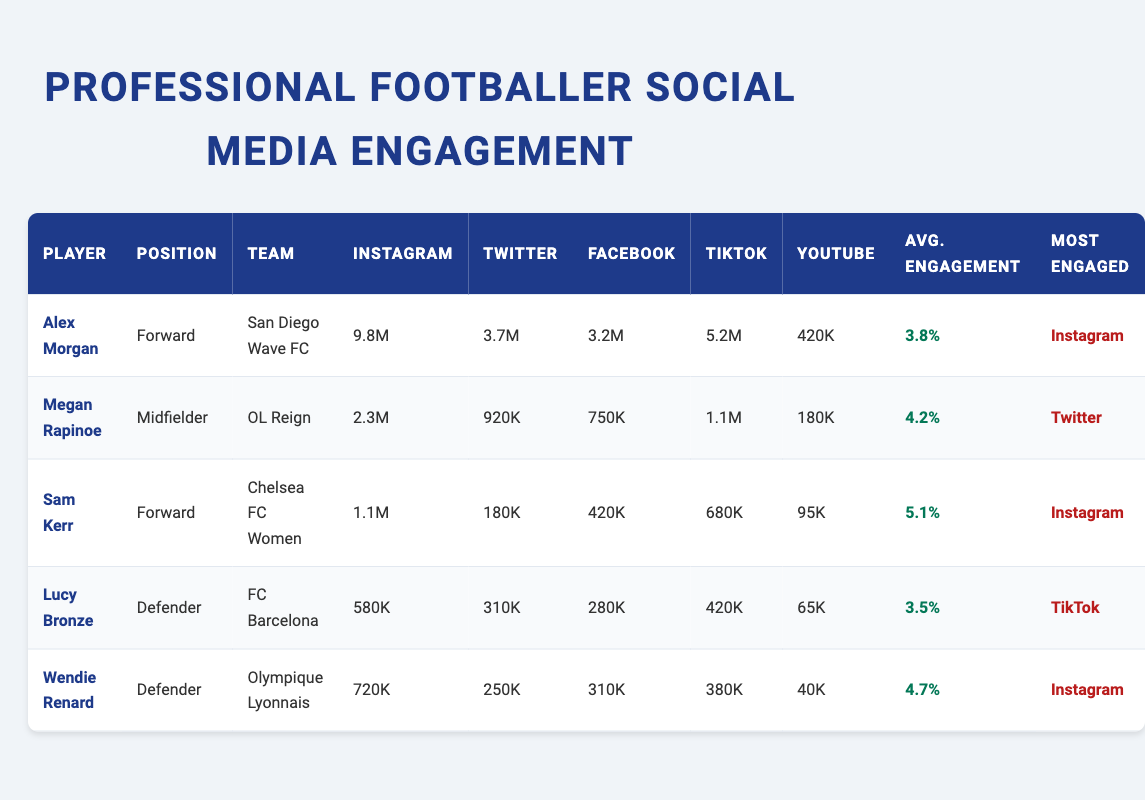What is the Instagram follow count for Alex Morgan? The Instagram follow count for Alex Morgan is listed directly in the table under the Instagram column. It shows 9.8 million followers.
Answer: 9.8 million Which player has the highest average post engagement rate? By reviewing the average engagement rates in the corresponding column, Sam Kerr has the highest rate at 5.1 percent, compared to others.
Answer: Sam Kerr What is the combined follower count for Megan Rapinoe across Instagram and TikTok? Megan Rapinoe has 2.3 million Instagram followers and 1.1 million TikTok followers. The combined count is 2.3 + 1.1 = 3.4 million.
Answer: 3.4 million Does Lucy Bronze have more TikTok followers than YouTube subscribers? In the table, Lucy Bronze has 420K TikTok followers and 65K YouTube subscribers. Since 420K is greater than 65K, the answer is yes.
Answer: Yes What is the average engagement rate for the players listed? To find the average, sum up the engagement rates: 3.8 + 4.2 + 5.1 + 3.5 + 4.7 = 21.3, then divide by 5 players gives 21.3 / 5 = 4.26.
Answer: 4.26 percent Which social media platform is most engaged for the majority of players? Review the "Most Engaged" column. Instagram appears frequently across Alex Morgan, Sam Kerr, and Wendie Renard, indicating it is the most engaged platform for the majority of players.
Answer: Instagram What is the difference in Facebook likes between Alex Morgan and Wendie Renard? Alex Morgan has 3.2 million Facebook likes and Wendie Renard has 310K. The difference is computed by subtracting: 3.2M - 310K = 2.89 million.
Answer: 2.89 million How many total subscribers do the players have on YouTube? Adding the YouTube subscribers: Alex Morgan (420K) + Megan Rapinoe (180K) + Sam Kerr (95K) + Lucy Bronze (65K) + Wendie Renard (40K) gives a total of 420 + 180 + 95 + 65 + 40 = 800K subscribers.
Answer: 800K subscribers 